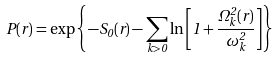Convert formula to latex. <formula><loc_0><loc_0><loc_500><loc_500>P ( r ) = \exp \left \{ - S _ { 0 } ( r ) - \sum _ { k > 0 } \ln \left [ 1 + \frac { \Omega _ { k } ^ { 2 } ( r ) } { \omega _ { k } ^ { 2 } } \right ] \right \}</formula> 